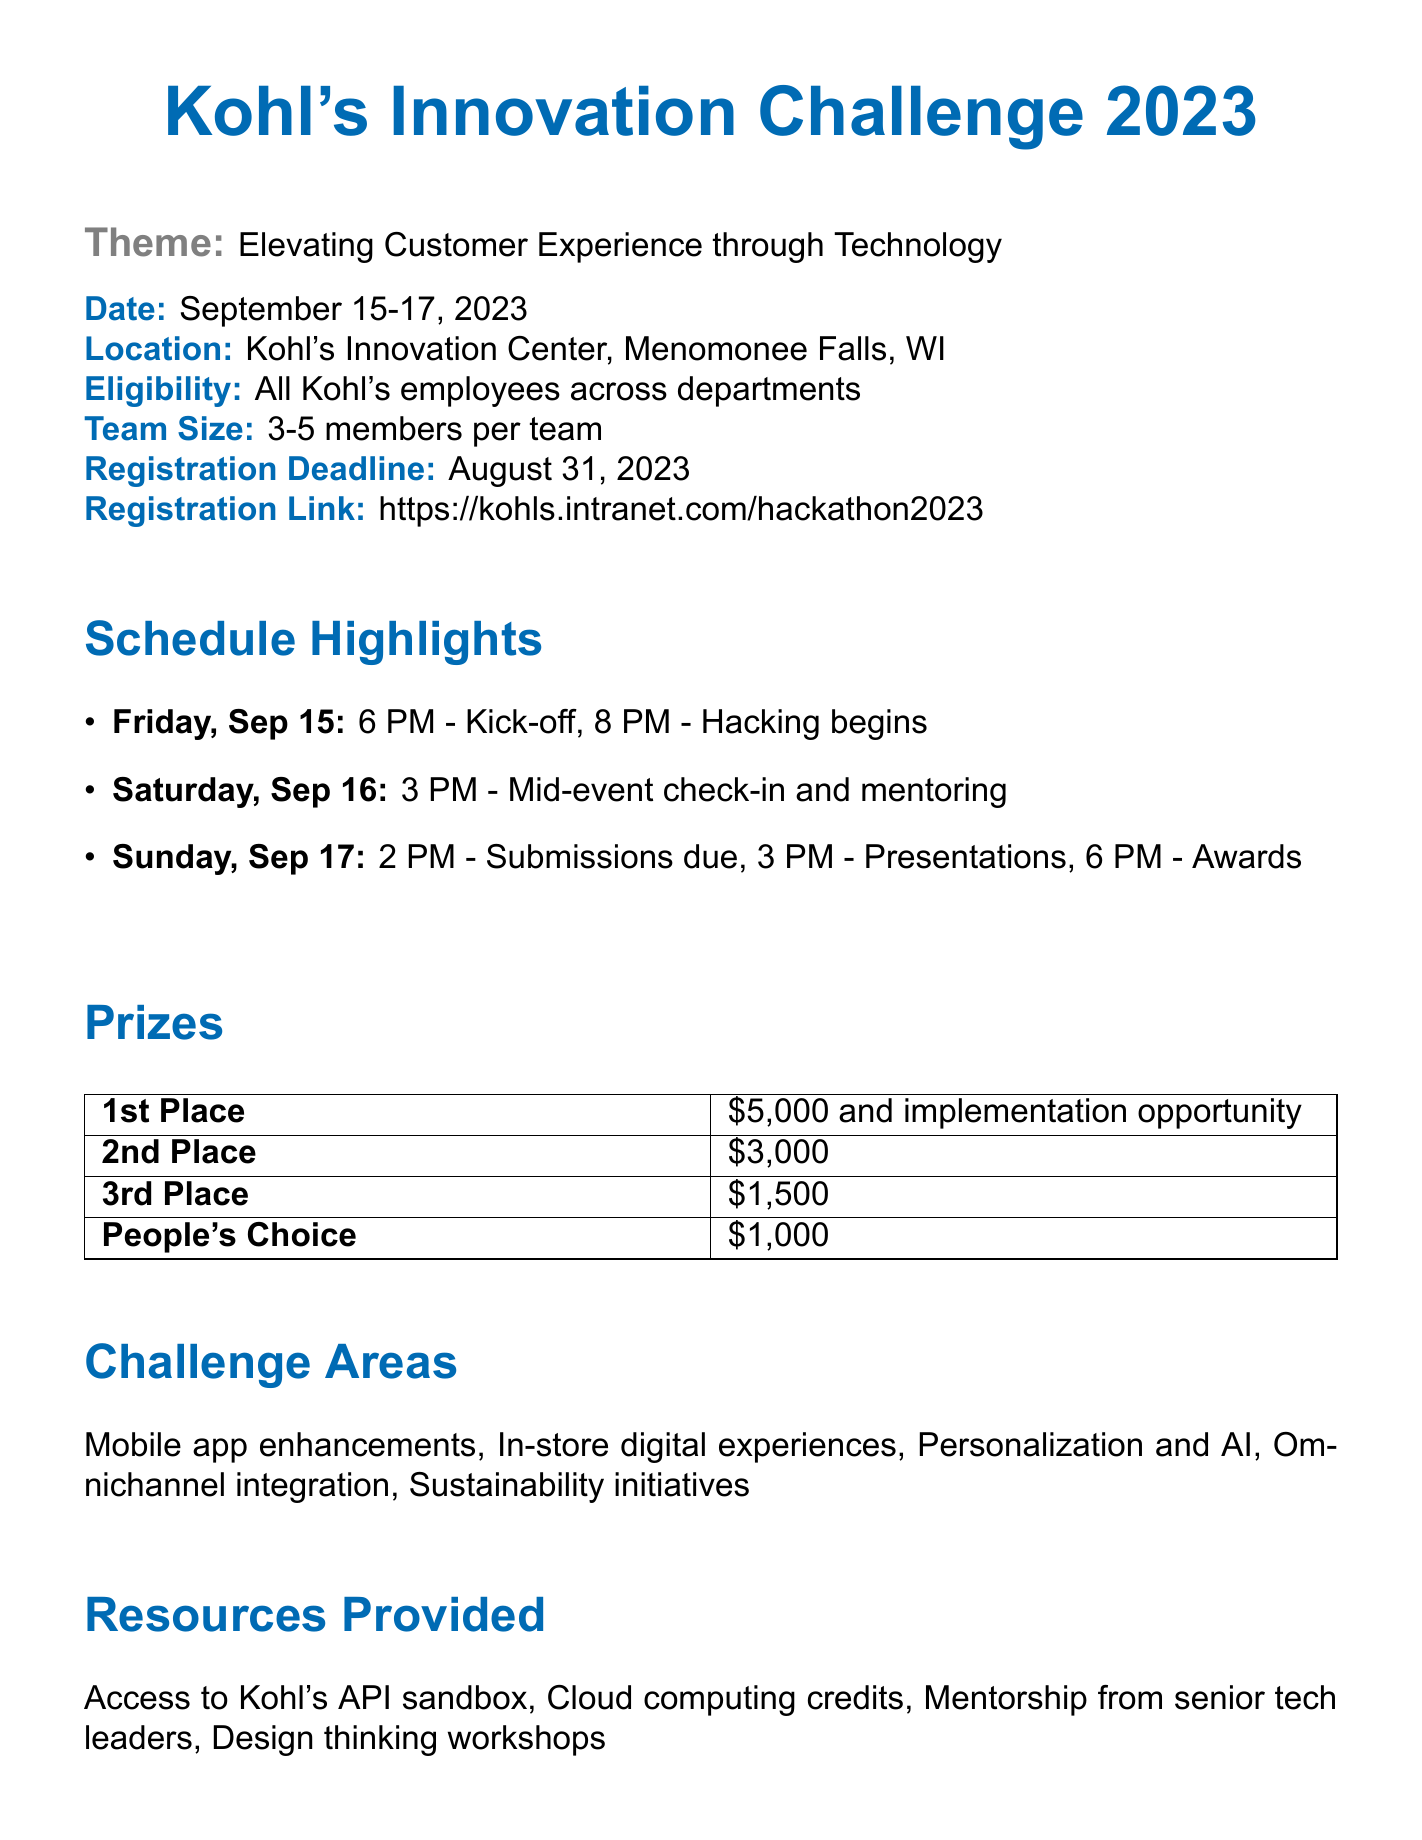What is the event name? The event is officially titled "Kohl's Innovation Challenge 2023", as stated at the beginning of the document.
Answer: Kohl's Innovation Challenge 2023 What is the theme of the hackathon? The theme is specifically mentioned in the memo as "Elevating Customer Experience through Technology".
Answer: Elevating Customer Experience through Technology When is the registration deadline? The memo specifies that the registration deadline is August 31, 2023.
Answer: August 31, 2023 What are the prizes for the 1st place? The document outlines that the 1st place prize consists of $5,000 and an implementation opportunity.
Answer: $5,000 and implementation opportunity How many members can be on a team? The document states that team sizes can range from 3 to 5 members per team.
Answer: 3-5 members per team Who can participate in the event? The memo indicates that eligibility extends to all Kohl's employees across departments.
Answer: All Kohl's employees across departments What is the location of the event? The location is specified in the document as "Kohl's Innovation Center, Menomonee Falls, WI".
Answer: Kohl's Innovation Center, Menomonee Falls, WI Which areas are included in the challenge? The areas outlined in the document for the challenge include mobile app enhancements, in-store digital experiences, personalization and AI, omnichannel integration, and sustainability initiatives.
Answer: Mobile app enhancements, in-store digital experiences, personalization and AI, omnichannel integration, sustainability initiatives Who is the contact person for the event? The contact person is mentioned in the document as Sarah Johnson, titled Innovation Program Manager.
Answer: Sarah Johnson What will be provided to participants? The document notes that meals, snacks, and beverages will be provided throughout the event.
Answer: Meals, snacks, and beverages 